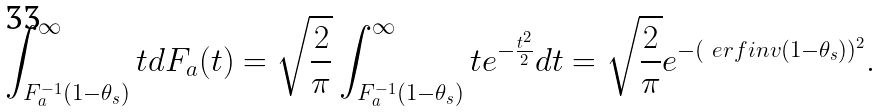<formula> <loc_0><loc_0><loc_500><loc_500>\int _ { F _ { a } ^ { - 1 } ( 1 - \theta _ { s } ) } ^ { \infty } t d F _ { a } ( t ) = \sqrt { \frac { 2 } { \pi } } \int _ { F _ { a } ^ { - 1 } ( 1 - \theta _ { s } ) } ^ { \infty } t e ^ { - \frac { t ^ { 2 } } { 2 } } d t = \sqrt { \frac { 2 } { \pi } } e ^ { - ( \ e r f i n v ( 1 - \theta _ { s } ) ) ^ { 2 } } .</formula> 